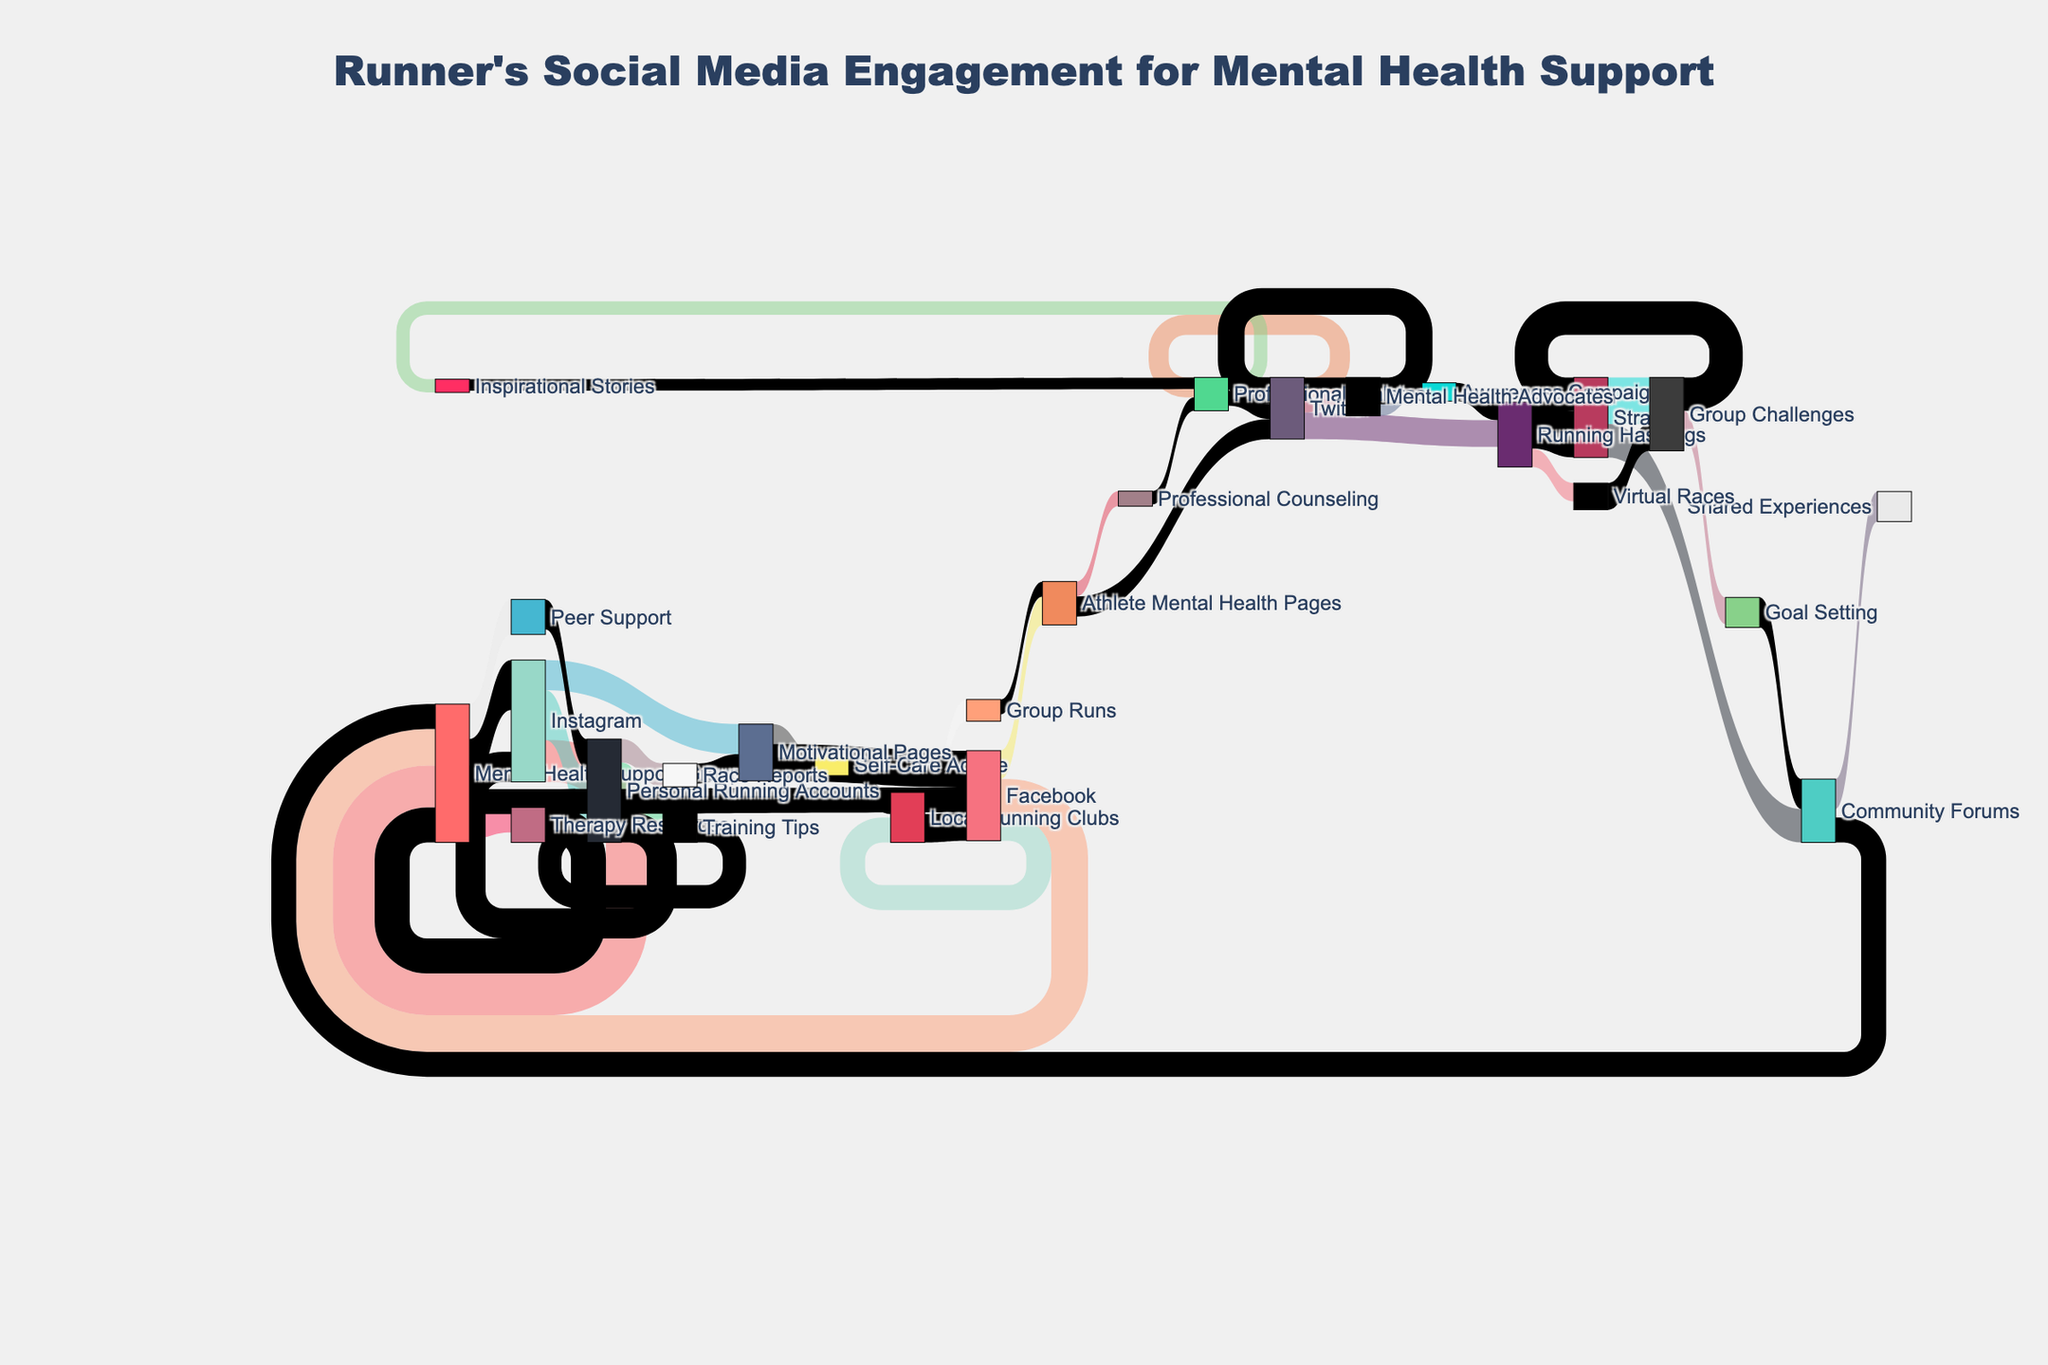What is the title of the Sankey diagram? The title of the Sankey diagram is mentioned at the top of the figure, centralised and highlighted in a larger font.
Answer: Runner's Social Media Engagement for Mental Health Support How many runners flow from Instagram to Personal Running Accounts? By following the link from Instagram to Personal Running Accounts, you can see the value associated with this flow.
Answer: 3000 Which source has the highest engagement value, and to which target does it connect? By comparing all the values from different sources, find the highest number and note the corresponding source and target.
Answer: Strava to Group Challenges What is the total engagement for runners connecting to Mental Health Support Groups across all platforms? Sum up all the values leading to Mental Health Support Groups from different sources (Instagram, Facebook, Twitter).
Answer: 2500 (Instagram) + 2200 (Facebook) = 4700 How does the engagement from Facebook to Local Running Clubs compare to Instagram to Motivational Pages? Compare the values directly connected from Facebook to Local Running Clubs and from Instagram to Motivational Pages.
Answer: 1500 (Facebook to Local Running Clubs) < 1800 (Instagram to Motivational Pages) Which target has the lower engagement value: Athlete Mental Health Pages or Professional Athletes on Twitter? Compare the values of the links to Athlete Mental Health Pages and Professional Athletes.
Answer: Athlete Mental Health Pages (1700 on Facebook) > Professional Athletes (1200 on Twitter) What is the combined engagement for runners flowing into Peer Support and Therapy Resources from Mental Health Support Groups? Add the values flowing into Peer Support and Therapy Resources from Mental Health Support Groups.
Answer: 1500 (Therapy Resources) + 2100 (Peer Support) = 3600 Which has greater engagement: runners connecting from Strava’s Group Challenges to Goal Setting or from its Community Forums to Shared Experiences? Compare the engagement values of runners flowing from Group Challenges to Goal Setting and from Community Forums to Shared Experiences.
Answer: 1600 (Goal Setting) < 1800 (Shared Experiences) How many platforms contribute engagement to Personal Running Accounts? Identify all unique sources contributing to Personal Running Accounts from the diagram.
Answer: 1 (Instagram) 